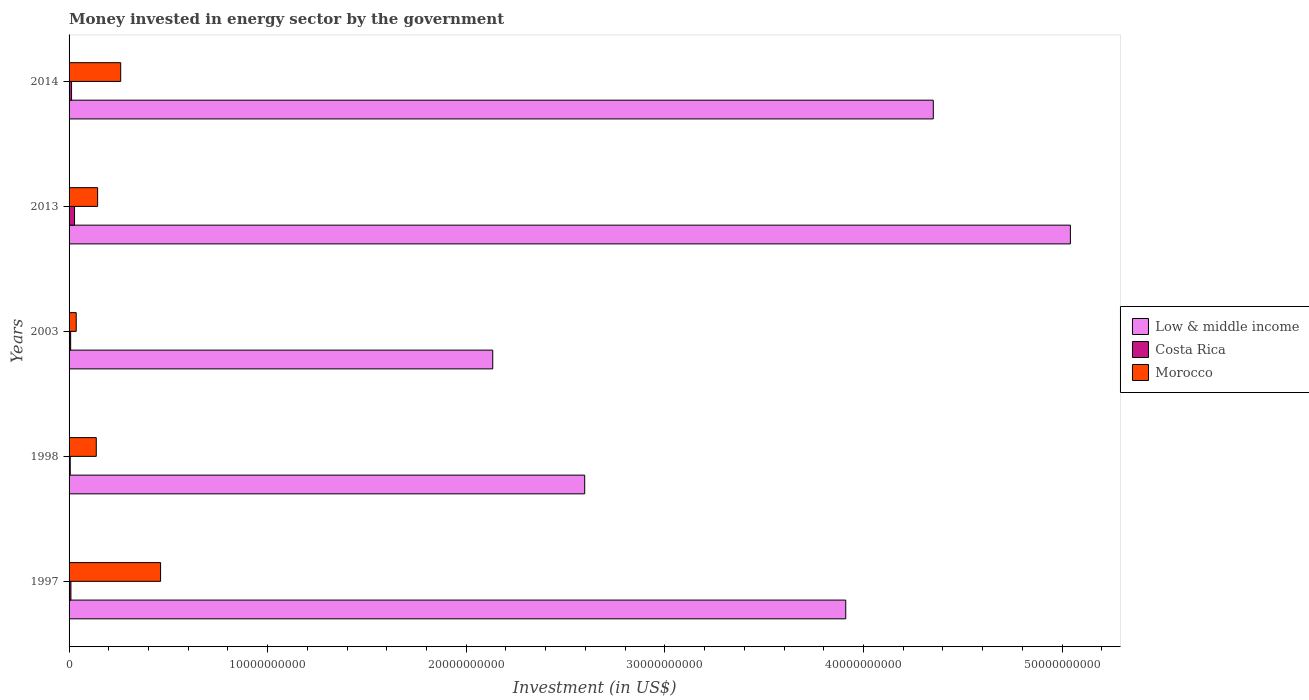How many different coloured bars are there?
Provide a short and direct response. 3. How many groups of bars are there?
Offer a very short reply. 5. How many bars are there on the 1st tick from the bottom?
Make the answer very short. 3. What is the label of the 2nd group of bars from the top?
Make the answer very short. 2013. What is the money spent in energy sector in Costa Rica in 1998?
Provide a short and direct response. 5.85e+07. Across all years, what is the maximum money spent in energy sector in Morocco?
Provide a short and direct response. 4.61e+09. Across all years, what is the minimum money spent in energy sector in Low & middle income?
Give a very brief answer. 2.13e+1. In which year was the money spent in energy sector in Costa Rica maximum?
Your answer should be very brief. 2013. What is the total money spent in energy sector in Morocco in the graph?
Your answer should be very brief. 1.04e+1. What is the difference between the money spent in energy sector in Costa Rica in 1997 and that in 2014?
Offer a terse response. -3.21e+07. What is the difference between the money spent in energy sector in Low & middle income in 1998 and the money spent in energy sector in Costa Rica in 1997?
Your response must be concise. 2.59e+1. What is the average money spent in energy sector in Costa Rica per year?
Offer a terse response. 1.26e+08. In the year 2014, what is the difference between the money spent in energy sector in Costa Rica and money spent in energy sector in Low & middle income?
Offer a terse response. -4.34e+1. Is the money spent in energy sector in Low & middle income in 2013 less than that in 2014?
Offer a very short reply. No. What is the difference between the highest and the second highest money spent in energy sector in Low & middle income?
Your response must be concise. 6.90e+09. What is the difference between the highest and the lowest money spent in energy sector in Costa Rica?
Offer a very short reply. 2.16e+08. In how many years, is the money spent in energy sector in Low & middle income greater than the average money spent in energy sector in Low & middle income taken over all years?
Offer a very short reply. 3. Is the sum of the money spent in energy sector in Morocco in 1997 and 1998 greater than the maximum money spent in energy sector in Low & middle income across all years?
Give a very brief answer. No. Is it the case that in every year, the sum of the money spent in energy sector in Morocco and money spent in energy sector in Low & middle income is greater than the money spent in energy sector in Costa Rica?
Your response must be concise. Yes. Are all the bars in the graph horizontal?
Make the answer very short. Yes. Are the values on the major ticks of X-axis written in scientific E-notation?
Your answer should be compact. No. Does the graph contain any zero values?
Your response must be concise. No. How many legend labels are there?
Keep it short and to the point. 3. How are the legend labels stacked?
Provide a short and direct response. Vertical. What is the title of the graph?
Provide a short and direct response. Money invested in energy sector by the government. Does "Malawi" appear as one of the legend labels in the graph?
Give a very brief answer. No. What is the label or title of the X-axis?
Your answer should be compact. Investment (in US$). What is the Investment (in US$) of Low & middle income in 1997?
Make the answer very short. 3.91e+1. What is the Investment (in US$) of Costa Rica in 1997?
Your response must be concise. 9.29e+07. What is the Investment (in US$) in Morocco in 1997?
Provide a succinct answer. 4.61e+09. What is the Investment (in US$) of Low & middle income in 1998?
Keep it short and to the point. 2.60e+1. What is the Investment (in US$) of Costa Rica in 1998?
Keep it short and to the point. 5.85e+07. What is the Investment (in US$) in Morocco in 1998?
Provide a short and direct response. 1.37e+09. What is the Investment (in US$) in Low & middle income in 2003?
Ensure brevity in your answer.  2.13e+1. What is the Investment (in US$) in Costa Rica in 2003?
Offer a very short reply. 8.00e+07. What is the Investment (in US$) in Morocco in 2003?
Your response must be concise. 3.60e+08. What is the Investment (in US$) of Low & middle income in 2013?
Your answer should be compact. 5.04e+1. What is the Investment (in US$) of Costa Rica in 2013?
Provide a succinct answer. 2.75e+08. What is the Investment (in US$) in Morocco in 2013?
Provide a short and direct response. 1.44e+09. What is the Investment (in US$) of Low & middle income in 2014?
Provide a short and direct response. 4.35e+1. What is the Investment (in US$) in Costa Rica in 2014?
Offer a very short reply. 1.25e+08. What is the Investment (in US$) in Morocco in 2014?
Make the answer very short. 2.60e+09. Across all years, what is the maximum Investment (in US$) of Low & middle income?
Offer a very short reply. 5.04e+1. Across all years, what is the maximum Investment (in US$) in Costa Rica?
Provide a short and direct response. 2.75e+08. Across all years, what is the maximum Investment (in US$) in Morocco?
Make the answer very short. 4.61e+09. Across all years, what is the minimum Investment (in US$) in Low & middle income?
Provide a short and direct response. 2.13e+1. Across all years, what is the minimum Investment (in US$) in Costa Rica?
Keep it short and to the point. 5.85e+07. Across all years, what is the minimum Investment (in US$) of Morocco?
Your answer should be compact. 3.60e+08. What is the total Investment (in US$) of Low & middle income in the graph?
Provide a short and direct response. 1.80e+11. What is the total Investment (in US$) in Costa Rica in the graph?
Ensure brevity in your answer.  6.31e+08. What is the total Investment (in US$) of Morocco in the graph?
Provide a succinct answer. 1.04e+1. What is the difference between the Investment (in US$) of Low & middle income in 1997 and that in 1998?
Your response must be concise. 1.31e+1. What is the difference between the Investment (in US$) in Costa Rica in 1997 and that in 1998?
Offer a very short reply. 3.44e+07. What is the difference between the Investment (in US$) in Morocco in 1997 and that in 1998?
Your answer should be compact. 3.24e+09. What is the difference between the Investment (in US$) in Low & middle income in 1997 and that in 2003?
Your answer should be very brief. 1.78e+1. What is the difference between the Investment (in US$) of Costa Rica in 1997 and that in 2003?
Give a very brief answer. 1.29e+07. What is the difference between the Investment (in US$) of Morocco in 1997 and that in 2003?
Provide a succinct answer. 4.25e+09. What is the difference between the Investment (in US$) of Low & middle income in 1997 and that in 2013?
Offer a very short reply. -1.13e+1. What is the difference between the Investment (in US$) of Costa Rica in 1997 and that in 2013?
Offer a terse response. -1.82e+08. What is the difference between the Investment (in US$) in Morocco in 1997 and that in 2013?
Offer a terse response. 3.17e+09. What is the difference between the Investment (in US$) in Low & middle income in 1997 and that in 2014?
Keep it short and to the point. -4.41e+09. What is the difference between the Investment (in US$) of Costa Rica in 1997 and that in 2014?
Give a very brief answer. -3.21e+07. What is the difference between the Investment (in US$) in Morocco in 1997 and that in 2014?
Provide a short and direct response. 2.01e+09. What is the difference between the Investment (in US$) in Low & middle income in 1998 and that in 2003?
Your answer should be compact. 4.63e+09. What is the difference between the Investment (in US$) in Costa Rica in 1998 and that in 2003?
Your answer should be compact. -2.15e+07. What is the difference between the Investment (in US$) in Morocco in 1998 and that in 2003?
Provide a succinct answer. 1.01e+09. What is the difference between the Investment (in US$) in Low & middle income in 1998 and that in 2013?
Ensure brevity in your answer.  -2.45e+1. What is the difference between the Investment (in US$) of Costa Rica in 1998 and that in 2013?
Your answer should be very brief. -2.16e+08. What is the difference between the Investment (in US$) of Morocco in 1998 and that in 2013?
Your answer should be compact. -6.80e+07. What is the difference between the Investment (in US$) in Low & middle income in 1998 and that in 2014?
Give a very brief answer. -1.76e+1. What is the difference between the Investment (in US$) in Costa Rica in 1998 and that in 2014?
Offer a terse response. -6.65e+07. What is the difference between the Investment (in US$) in Morocco in 1998 and that in 2014?
Keep it short and to the point. -1.23e+09. What is the difference between the Investment (in US$) of Low & middle income in 2003 and that in 2013?
Give a very brief answer. -2.91e+1. What is the difference between the Investment (in US$) in Costa Rica in 2003 and that in 2013?
Your answer should be compact. -1.95e+08. What is the difference between the Investment (in US$) of Morocco in 2003 and that in 2013?
Offer a terse response. -1.08e+09. What is the difference between the Investment (in US$) in Low & middle income in 2003 and that in 2014?
Your answer should be compact. -2.22e+1. What is the difference between the Investment (in US$) in Costa Rica in 2003 and that in 2014?
Your response must be concise. -4.50e+07. What is the difference between the Investment (in US$) in Morocco in 2003 and that in 2014?
Provide a succinct answer. -2.24e+09. What is the difference between the Investment (in US$) of Low & middle income in 2013 and that in 2014?
Give a very brief answer. 6.90e+09. What is the difference between the Investment (in US$) of Costa Rica in 2013 and that in 2014?
Keep it short and to the point. 1.50e+08. What is the difference between the Investment (in US$) in Morocco in 2013 and that in 2014?
Provide a succinct answer. -1.16e+09. What is the difference between the Investment (in US$) in Low & middle income in 1997 and the Investment (in US$) in Costa Rica in 1998?
Offer a terse response. 3.91e+1. What is the difference between the Investment (in US$) in Low & middle income in 1997 and the Investment (in US$) in Morocco in 1998?
Offer a terse response. 3.77e+1. What is the difference between the Investment (in US$) of Costa Rica in 1997 and the Investment (in US$) of Morocco in 1998?
Offer a very short reply. -1.28e+09. What is the difference between the Investment (in US$) of Low & middle income in 1997 and the Investment (in US$) of Costa Rica in 2003?
Your answer should be compact. 3.90e+1. What is the difference between the Investment (in US$) in Low & middle income in 1997 and the Investment (in US$) in Morocco in 2003?
Ensure brevity in your answer.  3.87e+1. What is the difference between the Investment (in US$) of Costa Rica in 1997 and the Investment (in US$) of Morocco in 2003?
Your response must be concise. -2.67e+08. What is the difference between the Investment (in US$) of Low & middle income in 1997 and the Investment (in US$) of Costa Rica in 2013?
Give a very brief answer. 3.88e+1. What is the difference between the Investment (in US$) in Low & middle income in 1997 and the Investment (in US$) in Morocco in 2013?
Your response must be concise. 3.77e+1. What is the difference between the Investment (in US$) in Costa Rica in 1997 and the Investment (in US$) in Morocco in 2013?
Your answer should be compact. -1.35e+09. What is the difference between the Investment (in US$) in Low & middle income in 1997 and the Investment (in US$) in Costa Rica in 2014?
Provide a succinct answer. 3.90e+1. What is the difference between the Investment (in US$) of Low & middle income in 1997 and the Investment (in US$) of Morocco in 2014?
Ensure brevity in your answer.  3.65e+1. What is the difference between the Investment (in US$) in Costa Rica in 1997 and the Investment (in US$) in Morocco in 2014?
Offer a terse response. -2.51e+09. What is the difference between the Investment (in US$) of Low & middle income in 1998 and the Investment (in US$) of Costa Rica in 2003?
Keep it short and to the point. 2.59e+1. What is the difference between the Investment (in US$) of Low & middle income in 1998 and the Investment (in US$) of Morocco in 2003?
Your answer should be compact. 2.56e+1. What is the difference between the Investment (in US$) of Costa Rica in 1998 and the Investment (in US$) of Morocco in 2003?
Your answer should be compact. -3.02e+08. What is the difference between the Investment (in US$) in Low & middle income in 1998 and the Investment (in US$) in Costa Rica in 2013?
Give a very brief answer. 2.57e+1. What is the difference between the Investment (in US$) in Low & middle income in 1998 and the Investment (in US$) in Morocco in 2013?
Offer a terse response. 2.45e+1. What is the difference between the Investment (in US$) in Costa Rica in 1998 and the Investment (in US$) in Morocco in 2013?
Offer a terse response. -1.38e+09. What is the difference between the Investment (in US$) of Low & middle income in 1998 and the Investment (in US$) of Costa Rica in 2014?
Offer a terse response. 2.58e+1. What is the difference between the Investment (in US$) in Low & middle income in 1998 and the Investment (in US$) in Morocco in 2014?
Your answer should be compact. 2.34e+1. What is the difference between the Investment (in US$) in Costa Rica in 1998 and the Investment (in US$) in Morocco in 2014?
Make the answer very short. -2.54e+09. What is the difference between the Investment (in US$) in Low & middle income in 2003 and the Investment (in US$) in Costa Rica in 2013?
Make the answer very short. 2.11e+1. What is the difference between the Investment (in US$) of Low & middle income in 2003 and the Investment (in US$) of Morocco in 2013?
Provide a succinct answer. 1.99e+1. What is the difference between the Investment (in US$) of Costa Rica in 2003 and the Investment (in US$) of Morocco in 2013?
Your answer should be very brief. -1.36e+09. What is the difference between the Investment (in US$) in Low & middle income in 2003 and the Investment (in US$) in Costa Rica in 2014?
Make the answer very short. 2.12e+1. What is the difference between the Investment (in US$) in Low & middle income in 2003 and the Investment (in US$) in Morocco in 2014?
Make the answer very short. 1.87e+1. What is the difference between the Investment (in US$) of Costa Rica in 2003 and the Investment (in US$) of Morocco in 2014?
Ensure brevity in your answer.  -2.52e+09. What is the difference between the Investment (in US$) of Low & middle income in 2013 and the Investment (in US$) of Costa Rica in 2014?
Give a very brief answer. 5.03e+1. What is the difference between the Investment (in US$) of Low & middle income in 2013 and the Investment (in US$) of Morocco in 2014?
Give a very brief answer. 4.78e+1. What is the difference between the Investment (in US$) in Costa Rica in 2013 and the Investment (in US$) in Morocco in 2014?
Give a very brief answer. -2.33e+09. What is the average Investment (in US$) of Low & middle income per year?
Your answer should be very brief. 3.61e+1. What is the average Investment (in US$) in Costa Rica per year?
Keep it short and to the point. 1.26e+08. What is the average Investment (in US$) of Morocco per year?
Keep it short and to the point. 2.08e+09. In the year 1997, what is the difference between the Investment (in US$) of Low & middle income and Investment (in US$) of Costa Rica?
Offer a very short reply. 3.90e+1. In the year 1997, what is the difference between the Investment (in US$) in Low & middle income and Investment (in US$) in Morocco?
Provide a succinct answer. 3.45e+1. In the year 1997, what is the difference between the Investment (in US$) in Costa Rica and Investment (in US$) in Morocco?
Offer a terse response. -4.52e+09. In the year 1998, what is the difference between the Investment (in US$) in Low & middle income and Investment (in US$) in Costa Rica?
Provide a short and direct response. 2.59e+1. In the year 1998, what is the difference between the Investment (in US$) in Low & middle income and Investment (in US$) in Morocco?
Your response must be concise. 2.46e+1. In the year 1998, what is the difference between the Investment (in US$) of Costa Rica and Investment (in US$) of Morocco?
Provide a short and direct response. -1.31e+09. In the year 2003, what is the difference between the Investment (in US$) in Low & middle income and Investment (in US$) in Costa Rica?
Your answer should be compact. 2.13e+1. In the year 2003, what is the difference between the Investment (in US$) of Low & middle income and Investment (in US$) of Morocco?
Keep it short and to the point. 2.10e+1. In the year 2003, what is the difference between the Investment (in US$) in Costa Rica and Investment (in US$) in Morocco?
Offer a terse response. -2.80e+08. In the year 2013, what is the difference between the Investment (in US$) in Low & middle income and Investment (in US$) in Costa Rica?
Ensure brevity in your answer.  5.01e+1. In the year 2013, what is the difference between the Investment (in US$) in Low & middle income and Investment (in US$) in Morocco?
Ensure brevity in your answer.  4.90e+1. In the year 2013, what is the difference between the Investment (in US$) in Costa Rica and Investment (in US$) in Morocco?
Offer a terse response. -1.16e+09. In the year 2014, what is the difference between the Investment (in US$) in Low & middle income and Investment (in US$) in Costa Rica?
Ensure brevity in your answer.  4.34e+1. In the year 2014, what is the difference between the Investment (in US$) of Low & middle income and Investment (in US$) of Morocco?
Your response must be concise. 4.09e+1. In the year 2014, what is the difference between the Investment (in US$) in Costa Rica and Investment (in US$) in Morocco?
Offer a very short reply. -2.48e+09. What is the ratio of the Investment (in US$) of Low & middle income in 1997 to that in 1998?
Offer a very short reply. 1.51. What is the ratio of the Investment (in US$) of Costa Rica in 1997 to that in 1998?
Offer a very short reply. 1.59. What is the ratio of the Investment (in US$) of Morocco in 1997 to that in 1998?
Make the answer very short. 3.36. What is the ratio of the Investment (in US$) in Low & middle income in 1997 to that in 2003?
Give a very brief answer. 1.83. What is the ratio of the Investment (in US$) in Costa Rica in 1997 to that in 2003?
Give a very brief answer. 1.16. What is the ratio of the Investment (in US$) in Morocco in 1997 to that in 2003?
Your answer should be very brief. 12.8. What is the ratio of the Investment (in US$) in Low & middle income in 1997 to that in 2013?
Ensure brevity in your answer.  0.78. What is the ratio of the Investment (in US$) in Costa Rica in 1997 to that in 2013?
Provide a succinct answer. 0.34. What is the ratio of the Investment (in US$) of Morocco in 1997 to that in 2013?
Give a very brief answer. 3.2. What is the ratio of the Investment (in US$) of Low & middle income in 1997 to that in 2014?
Your answer should be compact. 0.9. What is the ratio of the Investment (in US$) of Costa Rica in 1997 to that in 2014?
Ensure brevity in your answer.  0.74. What is the ratio of the Investment (in US$) of Morocco in 1997 to that in 2014?
Provide a succinct answer. 1.77. What is the ratio of the Investment (in US$) of Low & middle income in 1998 to that in 2003?
Give a very brief answer. 1.22. What is the ratio of the Investment (in US$) of Costa Rica in 1998 to that in 2003?
Your answer should be very brief. 0.73. What is the ratio of the Investment (in US$) in Morocco in 1998 to that in 2003?
Ensure brevity in your answer.  3.81. What is the ratio of the Investment (in US$) in Low & middle income in 1998 to that in 2013?
Your answer should be very brief. 0.52. What is the ratio of the Investment (in US$) of Costa Rica in 1998 to that in 2013?
Give a very brief answer. 0.21. What is the ratio of the Investment (in US$) in Morocco in 1998 to that in 2013?
Provide a succinct answer. 0.95. What is the ratio of the Investment (in US$) in Low & middle income in 1998 to that in 2014?
Offer a very short reply. 0.6. What is the ratio of the Investment (in US$) in Costa Rica in 1998 to that in 2014?
Your response must be concise. 0.47. What is the ratio of the Investment (in US$) of Morocco in 1998 to that in 2014?
Your answer should be compact. 0.53. What is the ratio of the Investment (in US$) in Low & middle income in 2003 to that in 2013?
Your answer should be compact. 0.42. What is the ratio of the Investment (in US$) of Costa Rica in 2003 to that in 2013?
Your response must be concise. 0.29. What is the ratio of the Investment (in US$) in Morocco in 2003 to that in 2013?
Offer a very short reply. 0.25. What is the ratio of the Investment (in US$) of Low & middle income in 2003 to that in 2014?
Provide a short and direct response. 0.49. What is the ratio of the Investment (in US$) of Costa Rica in 2003 to that in 2014?
Make the answer very short. 0.64. What is the ratio of the Investment (in US$) of Morocco in 2003 to that in 2014?
Keep it short and to the point. 0.14. What is the ratio of the Investment (in US$) of Low & middle income in 2013 to that in 2014?
Your answer should be compact. 1.16. What is the ratio of the Investment (in US$) in Costa Rica in 2013 to that in 2014?
Provide a short and direct response. 2.2. What is the ratio of the Investment (in US$) of Morocco in 2013 to that in 2014?
Your answer should be very brief. 0.55. What is the difference between the highest and the second highest Investment (in US$) in Low & middle income?
Provide a succinct answer. 6.90e+09. What is the difference between the highest and the second highest Investment (in US$) of Costa Rica?
Ensure brevity in your answer.  1.50e+08. What is the difference between the highest and the second highest Investment (in US$) in Morocco?
Offer a terse response. 2.01e+09. What is the difference between the highest and the lowest Investment (in US$) of Low & middle income?
Offer a terse response. 2.91e+1. What is the difference between the highest and the lowest Investment (in US$) in Costa Rica?
Offer a very short reply. 2.16e+08. What is the difference between the highest and the lowest Investment (in US$) of Morocco?
Offer a very short reply. 4.25e+09. 